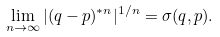Convert formula to latex. <formula><loc_0><loc_0><loc_500><loc_500>\lim _ { n \to \infty } | ( q - p ) ^ { * n } | ^ { 1 / n } = \sigma ( q , p ) .</formula> 